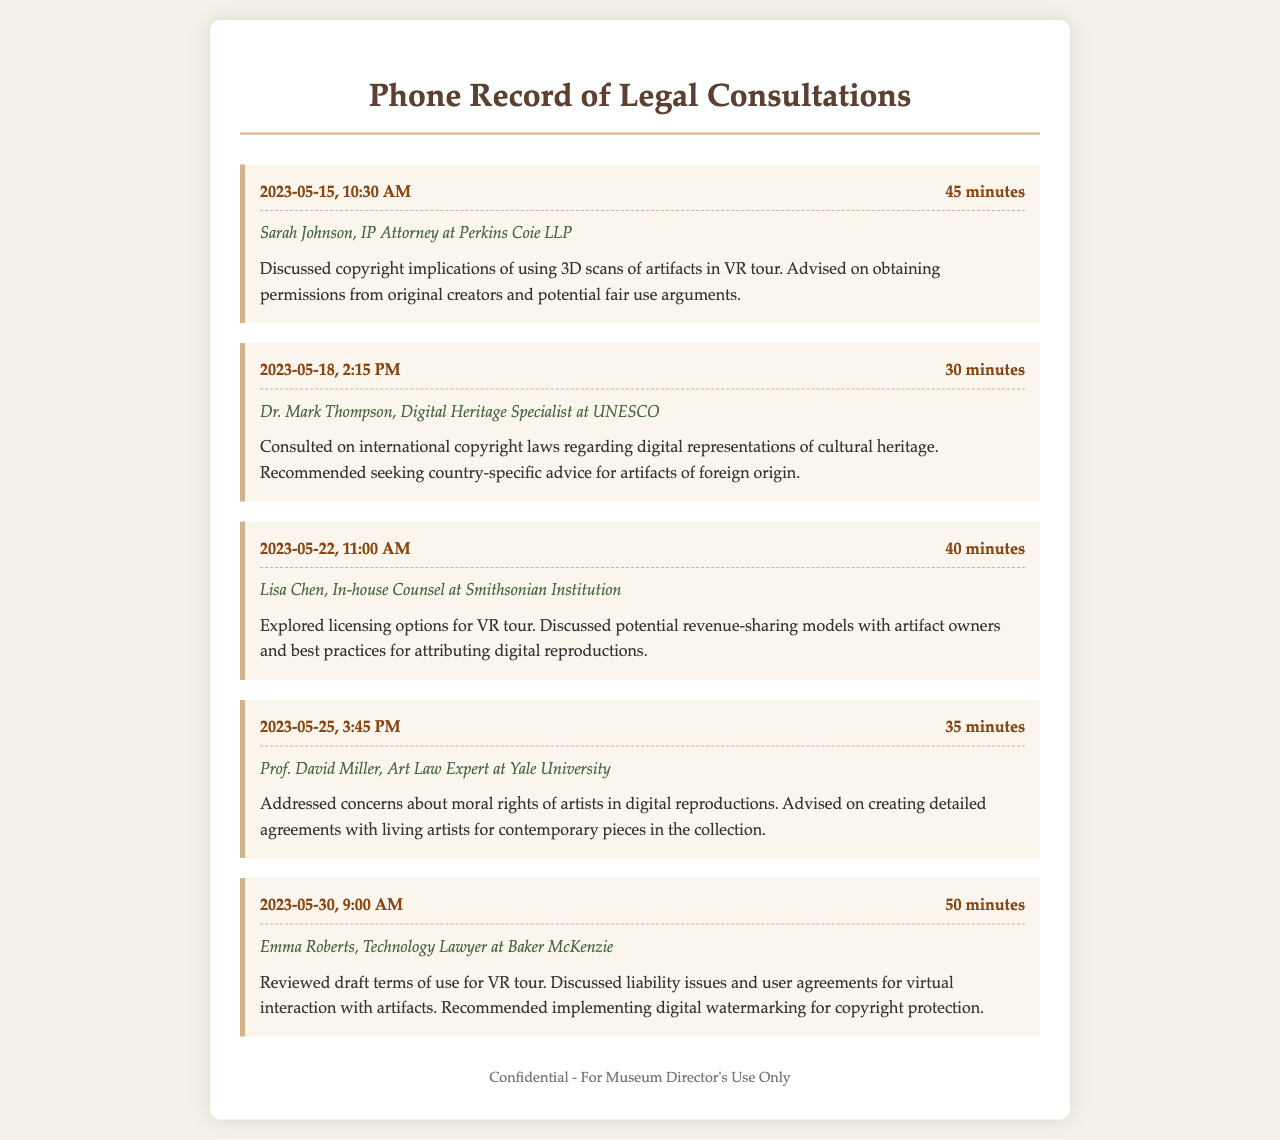What is the date of the first consultation? The first consultation took place on May 15, 2023.
Answer: May 15, 2023 Who was the contact for the second consultation? The second consultation was with Dr. Mark Thompson, a Digital Heritage Specialist at UNESCO.
Answer: Dr. Mark Thompson How long was the consultation with Lisa Chen? The duration of the consultation with Lisa Chen was 40 minutes.
Answer: 40 minutes What topic did Emma Roberts review during her consultation? Emma Roberts reviewed the draft terms of use for the VR tour.
Answer: draft terms of use What moral issue was discussed in the consultation with Prof. David Miller? Prof. David Miller addressed concerns about the moral rights of artists in digital reproductions.
Answer: moral rights of artists How many minutes was the consultation with Sarah Johnson? The consultation with Sarah Johnson lasted for 45 minutes.
Answer: 45 minutes 